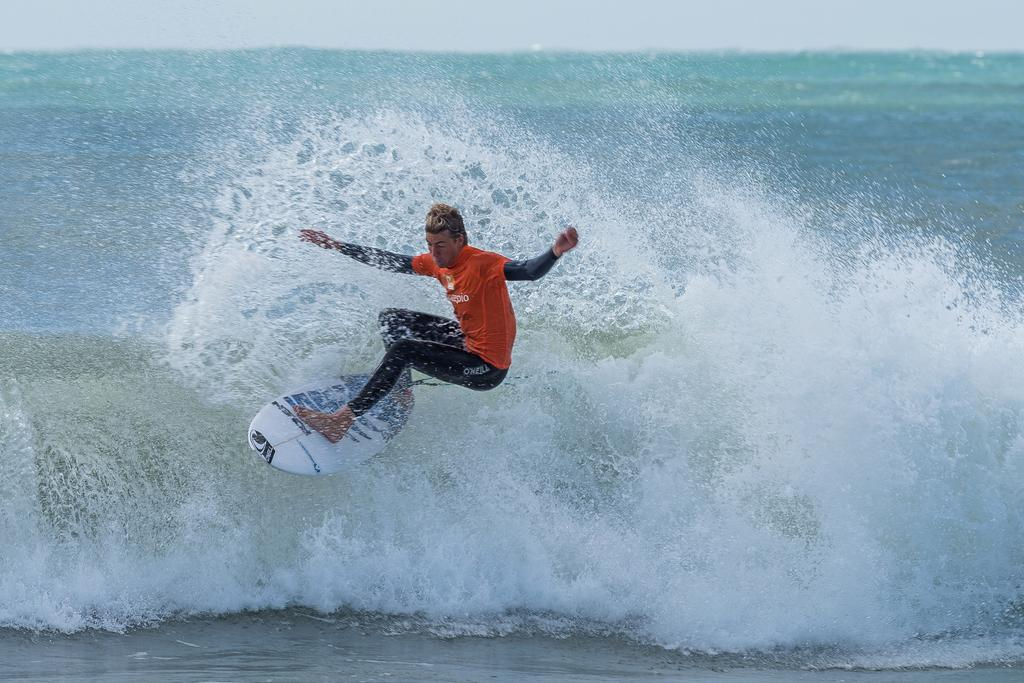<image>
Render a clear and concise summary of the photo. A surfer wearing black O'neal wetsuit pants rides a wave to shore 